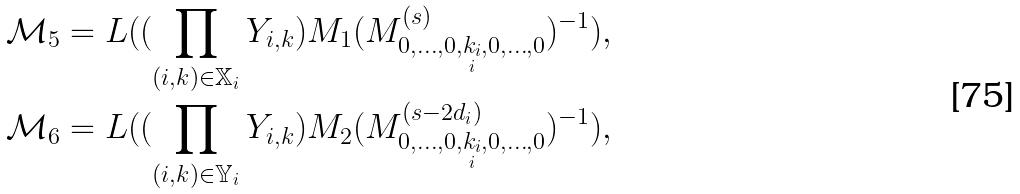Convert formula to latex. <formula><loc_0><loc_0><loc_500><loc_500>& \mathcal { M } _ { 5 } = L ( ( \prod _ { ( i , k ) \in \mathbb { X } _ { i } } Y _ { i , k } ) M _ { 1 } ( M ^ { ( s ) } _ { 0 , \dots , 0 , \underset { i } { k _ { i } } , 0 , \dots , 0 } ) ^ { - 1 } ) , \\ & \mathcal { M } _ { 6 } = L ( ( \prod _ { ( i , k ) \in \mathbb { Y } _ { i } } Y _ { i , k } ) M _ { 2 } ( M ^ { ( s - 2 d _ { i } ) } _ { 0 , \dots , 0 , \underset { i } { k _ { i } } , 0 , \dots , 0 } ) ^ { - 1 } ) ,</formula> 